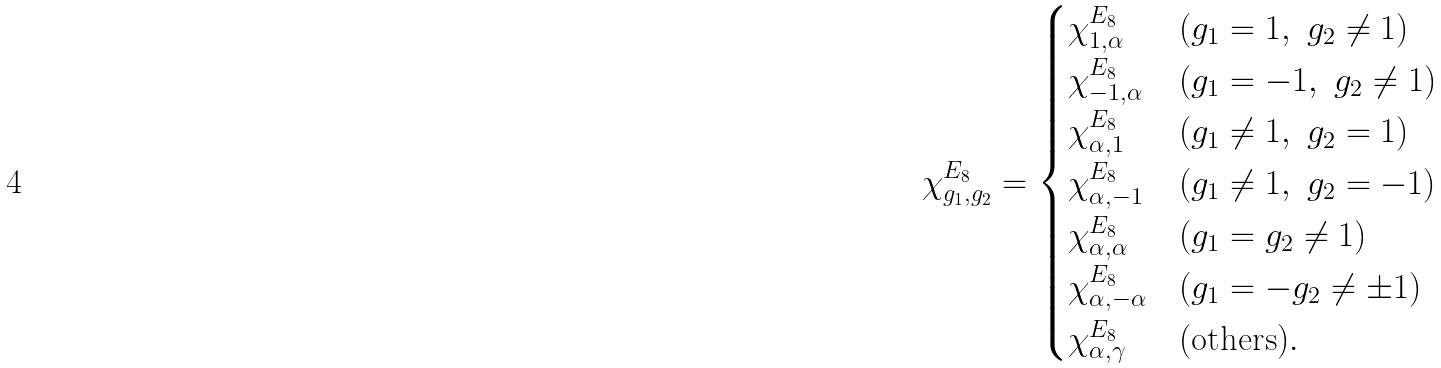<formula> <loc_0><loc_0><loc_500><loc_500>\chi ^ { E _ { 8 } } _ { g _ { 1 } , g _ { 2 } } = \begin{cases} \chi ^ { E _ { 8 } } _ { 1 , \alpha } & ( g _ { 1 } = 1 , \ g _ { 2 } \ne 1 ) \\ \chi ^ { E _ { 8 } } _ { - 1 , \alpha } & ( g _ { 1 } = - 1 , \ g _ { 2 } \ne 1 ) \\ \chi ^ { E _ { 8 } } _ { \alpha , 1 } & ( g _ { 1 } \ne 1 , \ g _ { 2 } = 1 ) \\ \chi ^ { E _ { 8 } } _ { \alpha , - 1 } & ( g _ { 1 } \ne 1 , \ g _ { 2 } = - 1 ) \\ \chi ^ { E _ { 8 } } _ { \alpha , \alpha } & ( g _ { 1 } = g _ { 2 } \ne 1 ) \\ \chi ^ { E _ { 8 } } _ { \alpha , - \alpha } & ( g _ { 1 } = - g _ { 2 } \ne \pm 1 ) \\ \chi ^ { E _ { 8 } } _ { \alpha , \gamma } & ( \text {others} ) . \\ \end{cases}</formula> 